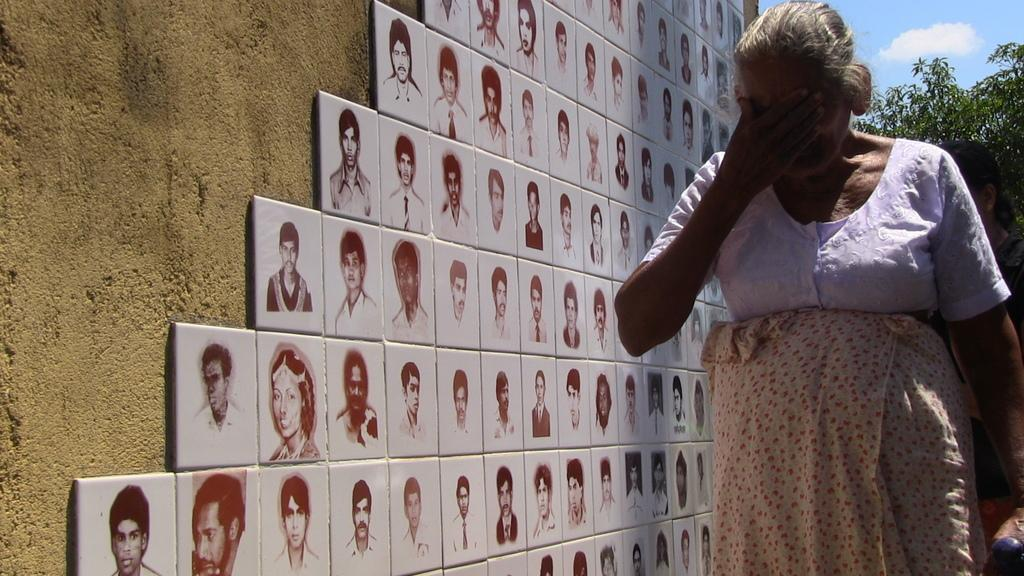Who is the main subject in the foreground of the image? There is an old woman in the foreground of the image. On which side of the image is the old woman located? The old woman is on the right side of the image. What type of flooring is visible in the foreground of the image? There are tiles in the foreground of the image. What can be seen on the wall in the image? There are pictures of people on the wall. On which side of the image are the pictures of people located? The pictures of people are on the left side of the image. What type of shoes is the old woman wearing on her back in the image? There is no mention of shoes or the old woman's back in the image; she is simply standing on the tiles in the foreground. 